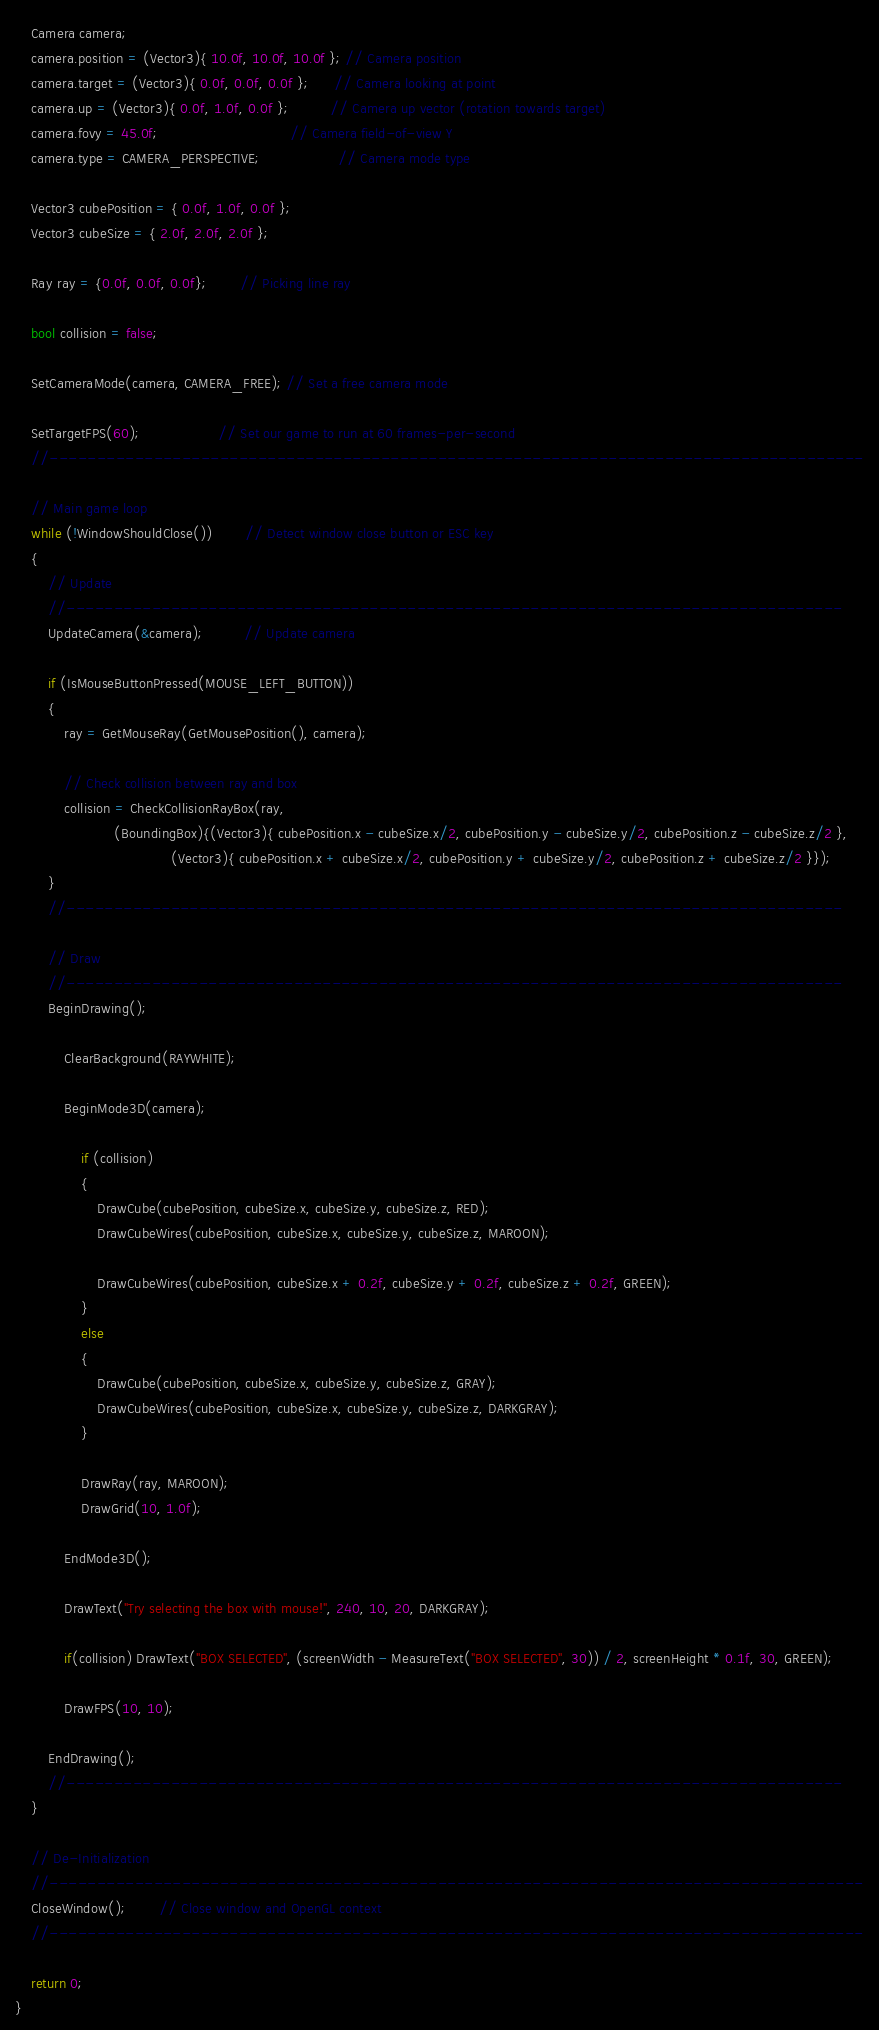Convert code to text. <code><loc_0><loc_0><loc_500><loc_500><_C_>    Camera camera;
    camera.position = (Vector3){ 10.0f, 10.0f, 10.0f }; // Camera position
    camera.target = (Vector3){ 0.0f, 0.0f, 0.0f };      // Camera looking at point
    camera.up = (Vector3){ 0.0f, 1.0f, 0.0f };          // Camera up vector (rotation towards target)
    camera.fovy = 45.0f;                                // Camera field-of-view Y
    camera.type = CAMERA_PERSPECTIVE;                   // Camera mode type

    Vector3 cubePosition = { 0.0f, 1.0f, 0.0f };
    Vector3 cubeSize = { 2.0f, 2.0f, 2.0f };

    Ray ray = {0.0f, 0.0f, 0.0f};        // Picking line ray

    bool collision = false;

    SetCameraMode(camera, CAMERA_FREE); // Set a free camera mode

    SetTargetFPS(60);                   // Set our game to run at 60 frames-per-second
    //--------------------------------------------------------------------------------------

    // Main game loop
    while (!WindowShouldClose())        // Detect window close button or ESC key
    {
        // Update
        //----------------------------------------------------------------------------------
        UpdateCamera(&camera);          // Update camera

        if (IsMouseButtonPressed(MOUSE_LEFT_BUTTON))
        {
            ray = GetMouseRay(GetMousePosition(), camera);

            // Check collision between ray and box
            collision = CheckCollisionRayBox(ray,
                        (BoundingBox){(Vector3){ cubePosition.x - cubeSize.x/2, cubePosition.y - cubeSize.y/2, cubePosition.z - cubeSize.z/2 },
                                      (Vector3){ cubePosition.x + cubeSize.x/2, cubePosition.y + cubeSize.y/2, cubePosition.z + cubeSize.z/2 }});
        }
        //----------------------------------------------------------------------------------

        // Draw
        //----------------------------------------------------------------------------------
        BeginDrawing();

            ClearBackground(RAYWHITE);

            BeginMode3D(camera);

                if (collision)
                {
                    DrawCube(cubePosition, cubeSize.x, cubeSize.y, cubeSize.z, RED);
                    DrawCubeWires(cubePosition, cubeSize.x, cubeSize.y, cubeSize.z, MAROON);

                    DrawCubeWires(cubePosition, cubeSize.x + 0.2f, cubeSize.y + 0.2f, cubeSize.z + 0.2f, GREEN);
                }
                else
                {
                    DrawCube(cubePosition, cubeSize.x, cubeSize.y, cubeSize.z, GRAY);
                    DrawCubeWires(cubePosition, cubeSize.x, cubeSize.y, cubeSize.z, DARKGRAY);
                }

                DrawRay(ray, MAROON);
                DrawGrid(10, 1.0f);

            EndMode3D();

            DrawText("Try selecting the box with mouse!", 240, 10, 20, DARKGRAY);

            if(collision) DrawText("BOX SELECTED", (screenWidth - MeasureText("BOX SELECTED", 30)) / 2, screenHeight * 0.1f, 30, GREEN);

            DrawFPS(10, 10);

        EndDrawing();
        //----------------------------------------------------------------------------------
    }

    // De-Initialization
    //--------------------------------------------------------------------------------------
    CloseWindow();        // Close window and OpenGL context
    //--------------------------------------------------------------------------------------

    return 0;
}
</code> 